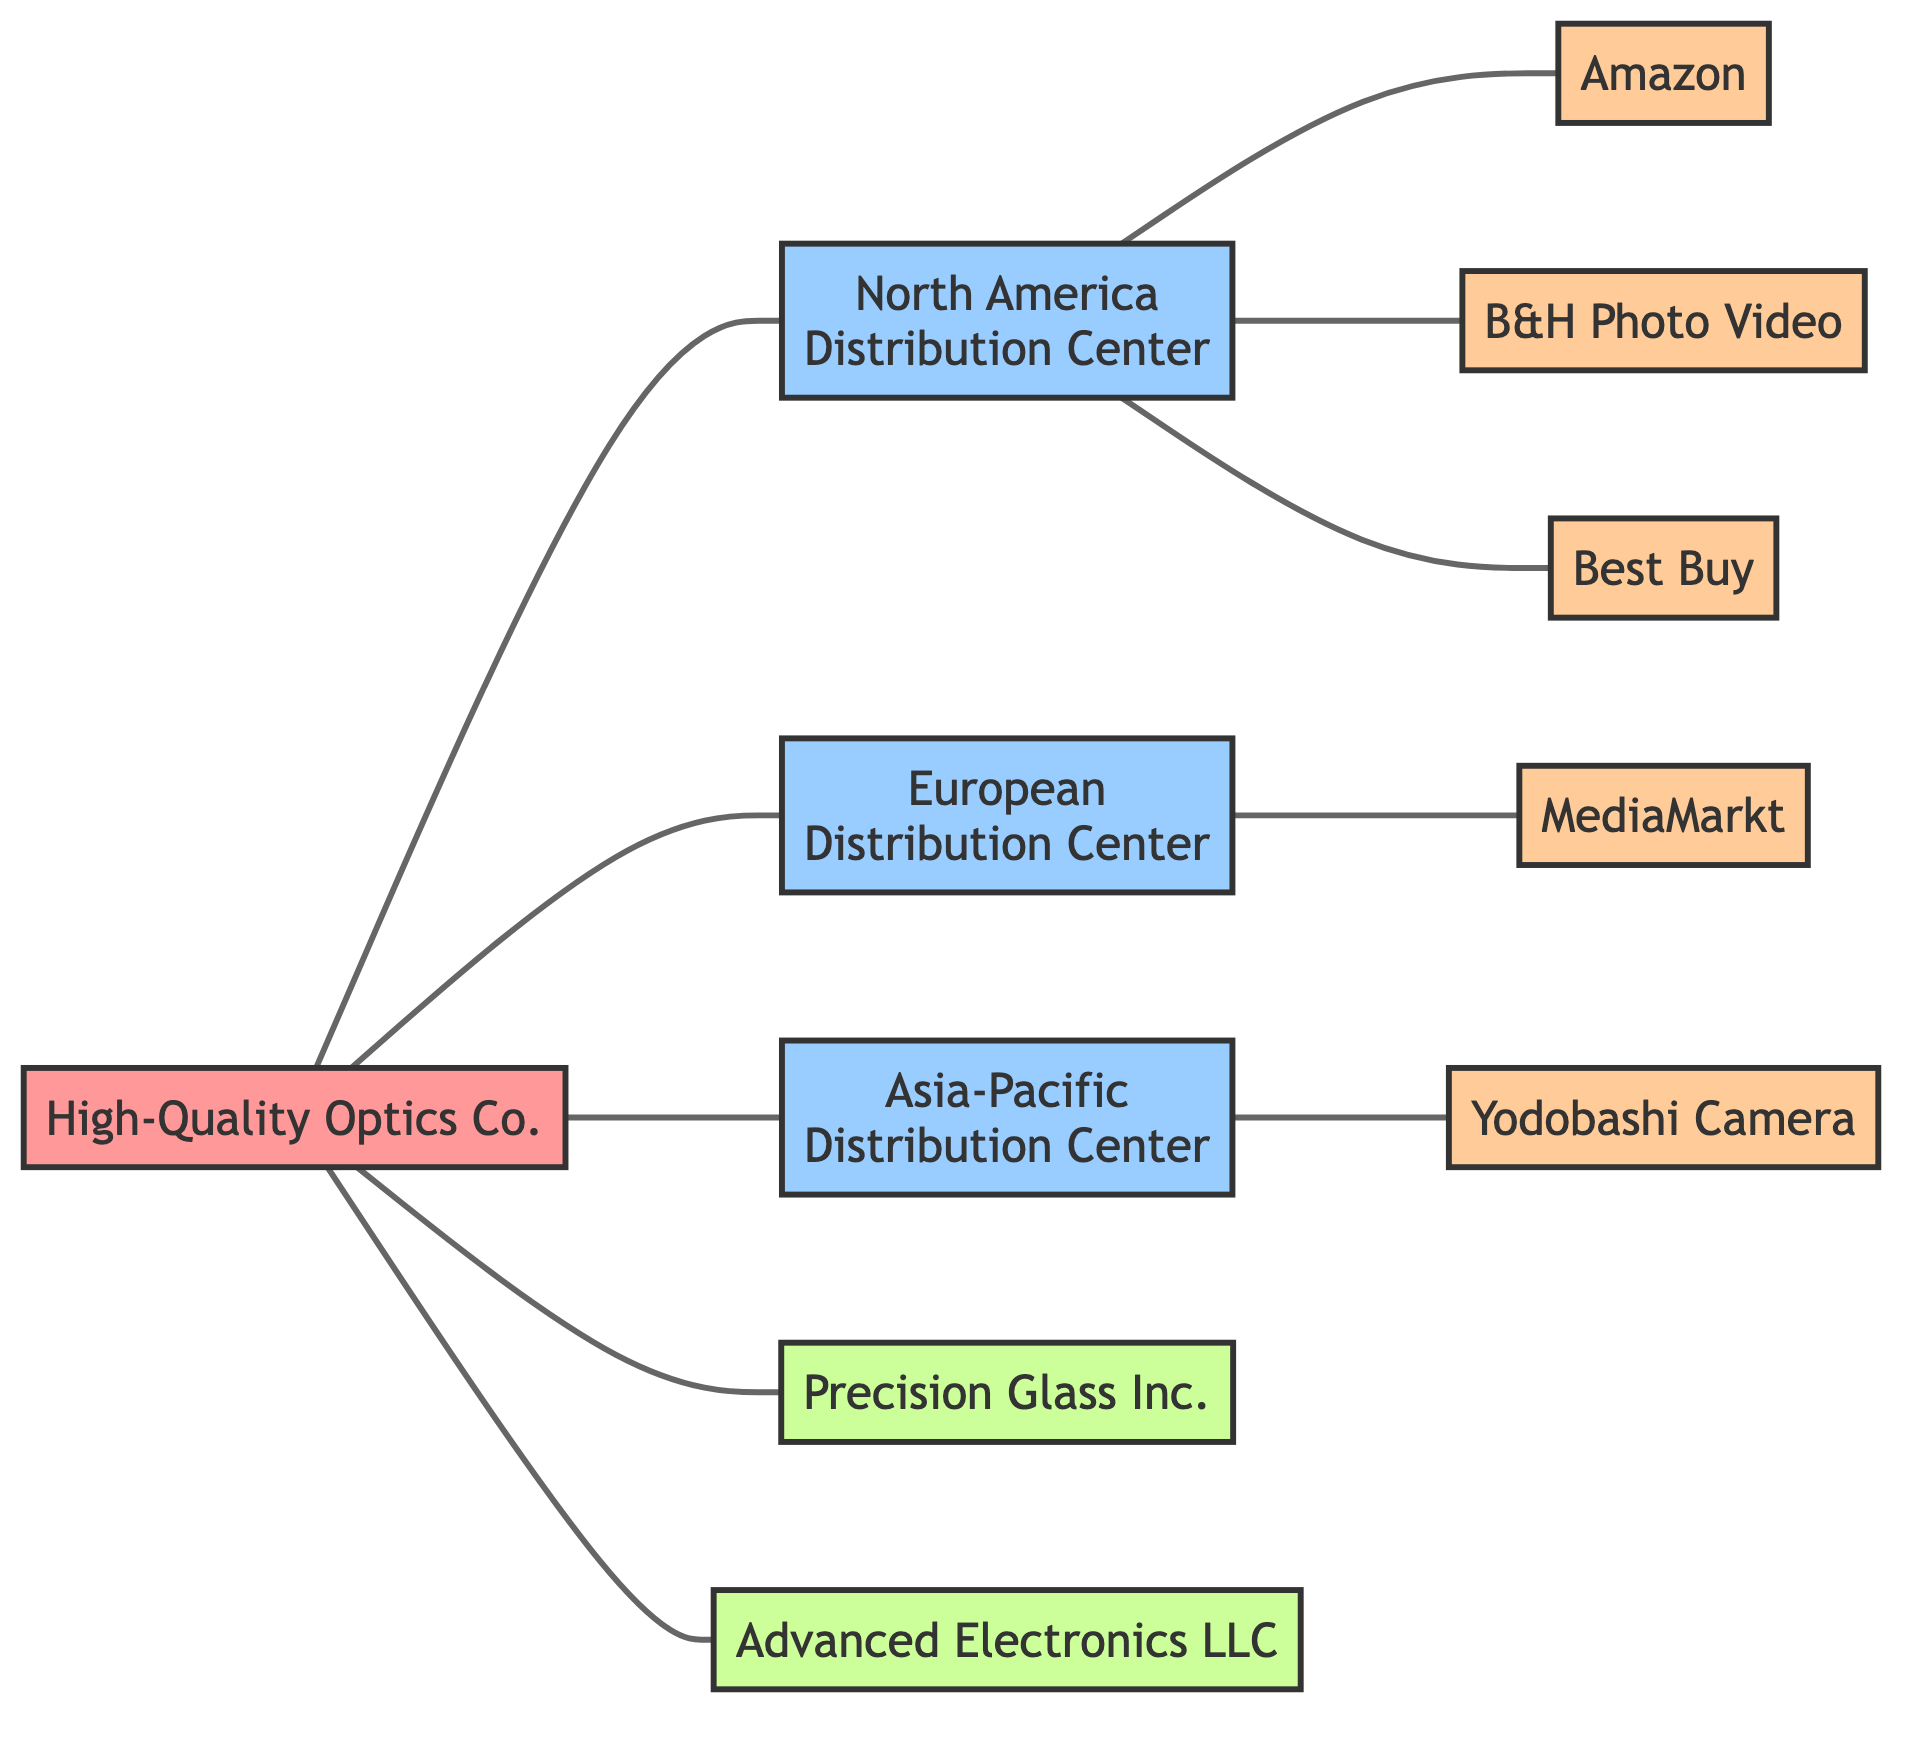What is the number of distribution centers in the diagram? The diagram lists three distribution centers: North America Distribution Center, European Distribution Center, and Asia-Pacific Distribution Center. Therefore, the total count is three.
Answer: 3 Which retailer is connected to the North America Distribution Center? The diagram shows three retailers connected to the North America Distribution Center: Amazon, B&H Photo Video, and Best Buy. Any of these retailers can be considered as the answer, but I'll list the first one for clarity.
Answer: Amazon How many suppliers are connected to the manufacturer? The diagram indicates that two suppliers are connected to the manufacturer: Precision Glass Inc. and Advanced Electronics LLC. Hence, the total number of suppliers connected is two.
Answer: 2 Which distribution center connects to retailers in Europe? The diagram clearly shows that the European Distribution Center is connected to MediaMarkt. This is the only retailer linked to this distribution center in the diagram.
Answer: MediaMarkt What is the relationship between High-Quality Optics Co. and Asia-Pacific Distribution Center? The relationship in the diagram is a direct connection, indicating that High-Quality Optics Co. supplies products directly to the Asia-Pacific Distribution Center.
Answer: Direct connection How many retailers are connected to the North America Distribution Center? The North America Distribution Center has three retailers connected to it, as shown in the diagram: Amazon, B&H Photo Video, and Best Buy. Hence, the count is three.
Answer: 3 What is the connection type of the graph that represents the distribution network? The graph is an undirected graph, which means the edges do not have a direction. Connections between nodes can be traversed in both ways.
Answer: Undirected How many total edges are present in the diagram? By counting the connections in the edges list, it can be determined there are 9 edges in total. This involves checking each line that indicates a connection between two nodes.
Answer: 9 Which supplier is directly connected to High-Quality Optics Co.? The diagram indicates that both Precision Glass Inc. and Advanced Electronics LLC are directly connected to High-Quality Optics Co., showing a direct supplier-manufacturer relationship. The answer will include the first listed supplier.
Answer: Precision Glass Inc 